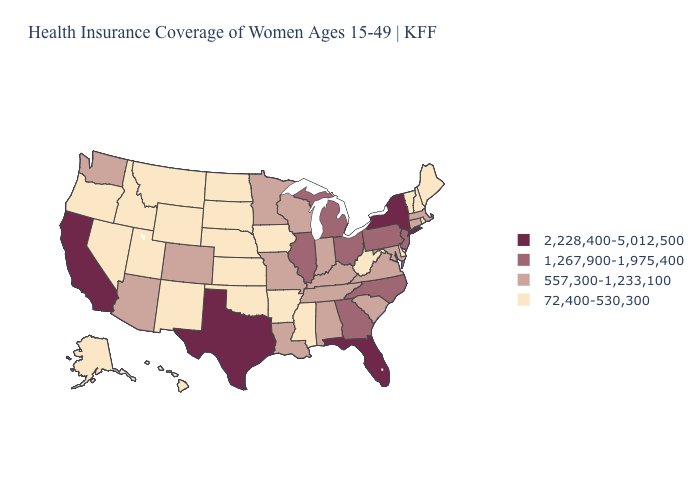Is the legend a continuous bar?
Give a very brief answer. No. What is the value of Alabama?
Give a very brief answer. 557,300-1,233,100. What is the value of Missouri?
Answer briefly. 557,300-1,233,100. Does California have the highest value in the West?
Short answer required. Yes. What is the lowest value in the West?
Short answer required. 72,400-530,300. What is the value of Pennsylvania?
Be succinct. 1,267,900-1,975,400. What is the value of Florida?
Write a very short answer. 2,228,400-5,012,500. Does New York have the highest value in the Northeast?
Give a very brief answer. Yes. Does the map have missing data?
Be succinct. No. Does Arkansas have the lowest value in the South?
Keep it brief. Yes. Does Arkansas have the lowest value in the South?
Quick response, please. Yes. Which states hav the highest value in the MidWest?
Give a very brief answer. Illinois, Michigan, Ohio. What is the lowest value in the USA?
Keep it brief. 72,400-530,300. What is the value of Pennsylvania?
Short answer required. 1,267,900-1,975,400. What is the value of Alaska?
Be succinct. 72,400-530,300. 